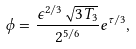<formula> <loc_0><loc_0><loc_500><loc_500>\phi = \frac { \epsilon ^ { 2 / 3 } \sqrt { 3 T _ { 3 } } } { 2 ^ { 5 / 6 } } e ^ { \tau / 3 } ,</formula> 